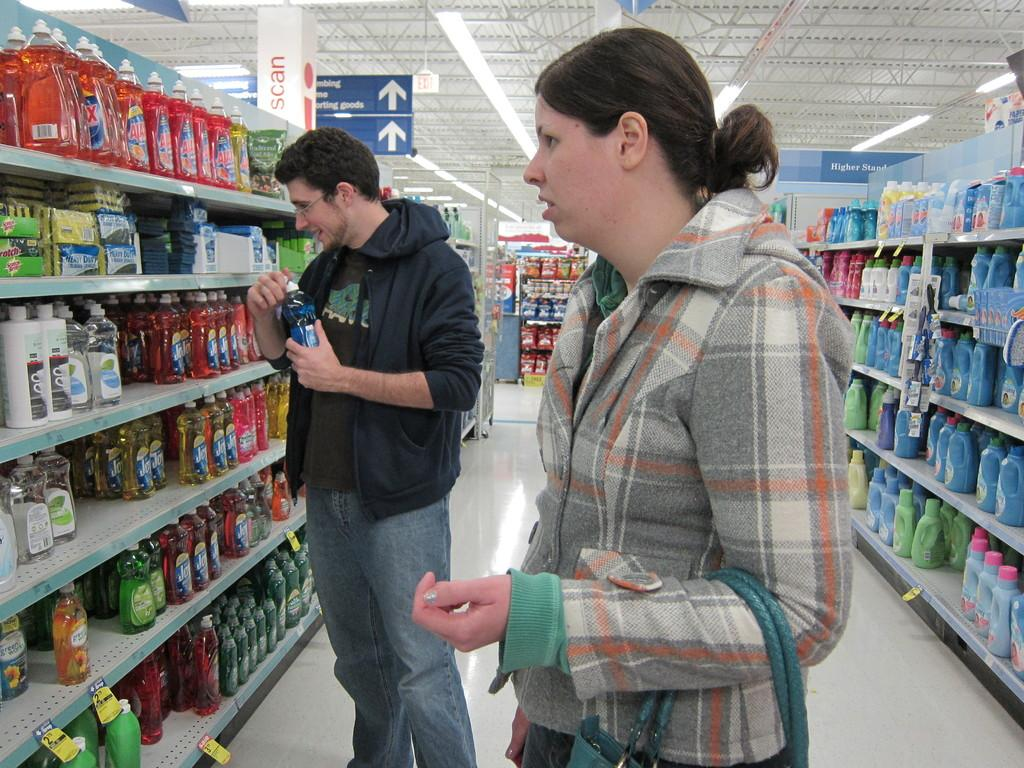<image>
Present a compact description of the photo's key features. A man stands in front of shelves full of bottles of Ajax and Dawn and other dish soaps. 